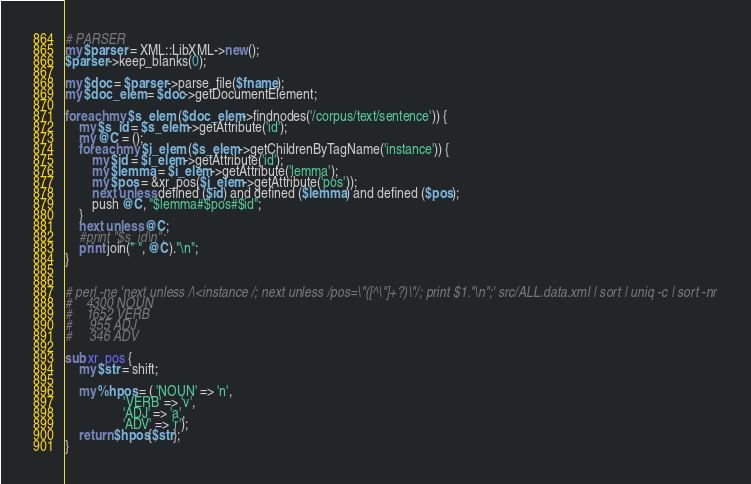Convert code to text. <code><loc_0><loc_0><loc_500><loc_500><_Perl_># PARSER
my $parser = XML::LibXML->new();
$parser->keep_blanks(0);

my $doc = $parser->parse_file($fname);
my $doc_elem = $doc->getDocumentElement;

foreach my $s_elem ($doc_elem->findnodes('/corpus/text/sentence')) {
	my $s_id = $s_elem->getAttribute('id');
	my @C = ();
	foreach my $i_elem ($s_elem->getChildrenByTagName('instance')) {
		my $id = $i_elem->getAttribute('id');
		my $lemma = $i_elem->getAttribute('lemma');
		my $pos = &xr_pos($i_elem->getAttribute('pos'));
		next unless defined ($id) and defined ($lemma) and defined ($pos);
		push @C, "$lemma#$pos#$id";
	}
	next unless @C;
	#print "$s_id\n";
	print join(" ", @C)."\n";
}


# perl -ne 'next unless /\<instance /; next unless /pos=\"([^\"]+?)\"/; print $1."\n";' src/ALL.data.xml | sort | uniq -c | sort -nr
#    4300 NOUN
#    1652 VERB
#     955 ADJ
#     346 ADV

sub xr_pos {
	my $str = shift;

	my %hpos = ( 'NOUN' => 'n',
				 'VERB' => 'v',
				 'ADJ' => 'a',
				 'ADV' => 'r');
	return $hpos{$str};
}
</code> 